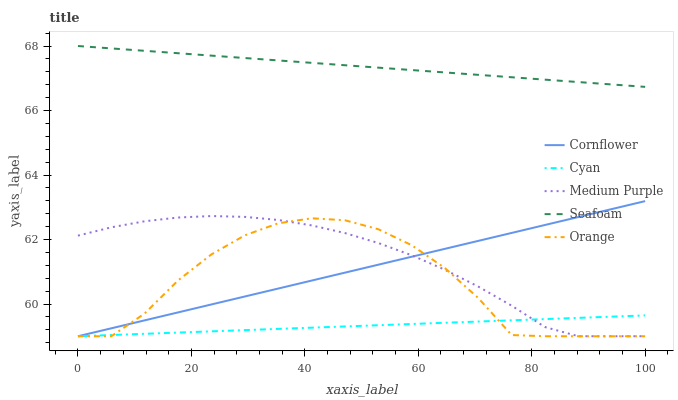Does Cyan have the minimum area under the curve?
Answer yes or no. Yes. Does Seafoam have the maximum area under the curve?
Answer yes or no. Yes. Does Cornflower have the minimum area under the curve?
Answer yes or no. No. Does Cornflower have the maximum area under the curve?
Answer yes or no. No. Is Cyan the smoothest?
Answer yes or no. Yes. Is Orange the roughest?
Answer yes or no. Yes. Is Cornflower the smoothest?
Answer yes or no. No. Is Cornflower the roughest?
Answer yes or no. No. Does Medium Purple have the lowest value?
Answer yes or no. Yes. Does Seafoam have the lowest value?
Answer yes or no. No. Does Seafoam have the highest value?
Answer yes or no. Yes. Does Cornflower have the highest value?
Answer yes or no. No. Is Orange less than Seafoam?
Answer yes or no. Yes. Is Seafoam greater than Cyan?
Answer yes or no. Yes. Does Cornflower intersect Cyan?
Answer yes or no. Yes. Is Cornflower less than Cyan?
Answer yes or no. No. Is Cornflower greater than Cyan?
Answer yes or no. No. Does Orange intersect Seafoam?
Answer yes or no. No. 